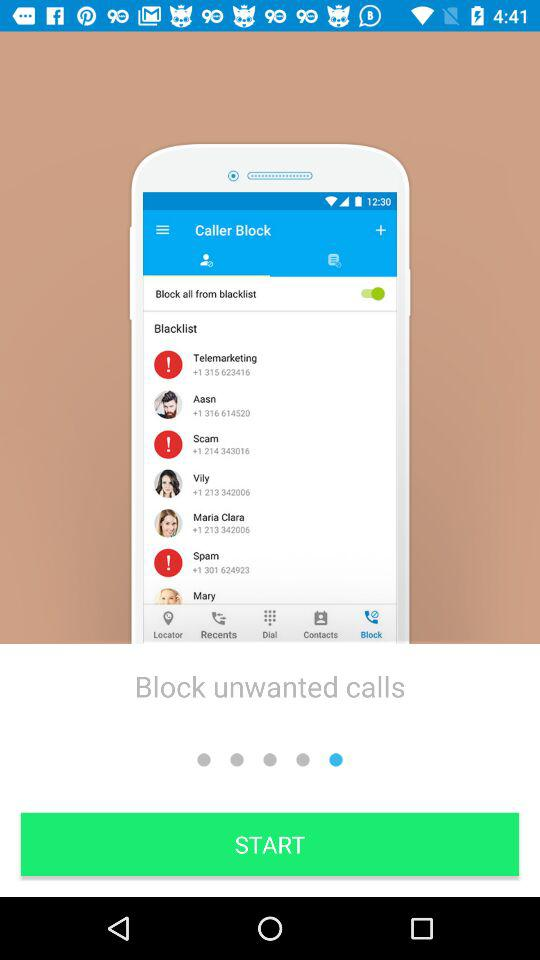Which functionality is shown on the screen?
When the provided information is insufficient, respond with <no answer>. <no answer> 